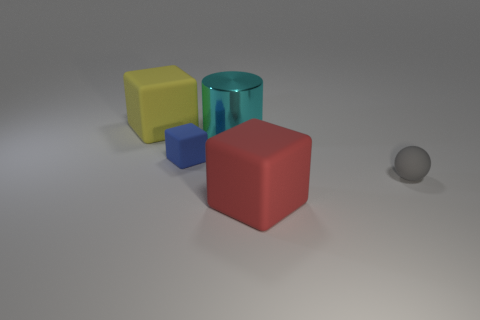Is the number of small blocks in front of the red rubber block the same as the number of large yellow things that are right of the big metallic cylinder?
Your answer should be very brief. Yes. The large object that is both to the left of the red matte cube and on the right side of the tiny blue block is what color?
Keep it short and to the point. Cyan. There is a large cylinder to the left of the large matte block that is to the right of the metal object; what is its material?
Provide a short and direct response. Metal. Does the cylinder have the same size as the blue matte object?
Keep it short and to the point. No. How many small things are either red things or blocks?
Your response must be concise. 1. What number of tiny blue matte cubes are behind the cyan cylinder?
Your response must be concise. 0. Is the number of red matte objects that are right of the gray thing greater than the number of big gray shiny spheres?
Your answer should be very brief. No. What is the shape of the large red thing that is made of the same material as the tiny gray ball?
Your answer should be compact. Cube. What color is the small rubber object left of the big rubber thing right of the large cyan thing?
Give a very brief answer. Blue. Does the big red thing have the same shape as the small blue matte thing?
Keep it short and to the point. Yes. 